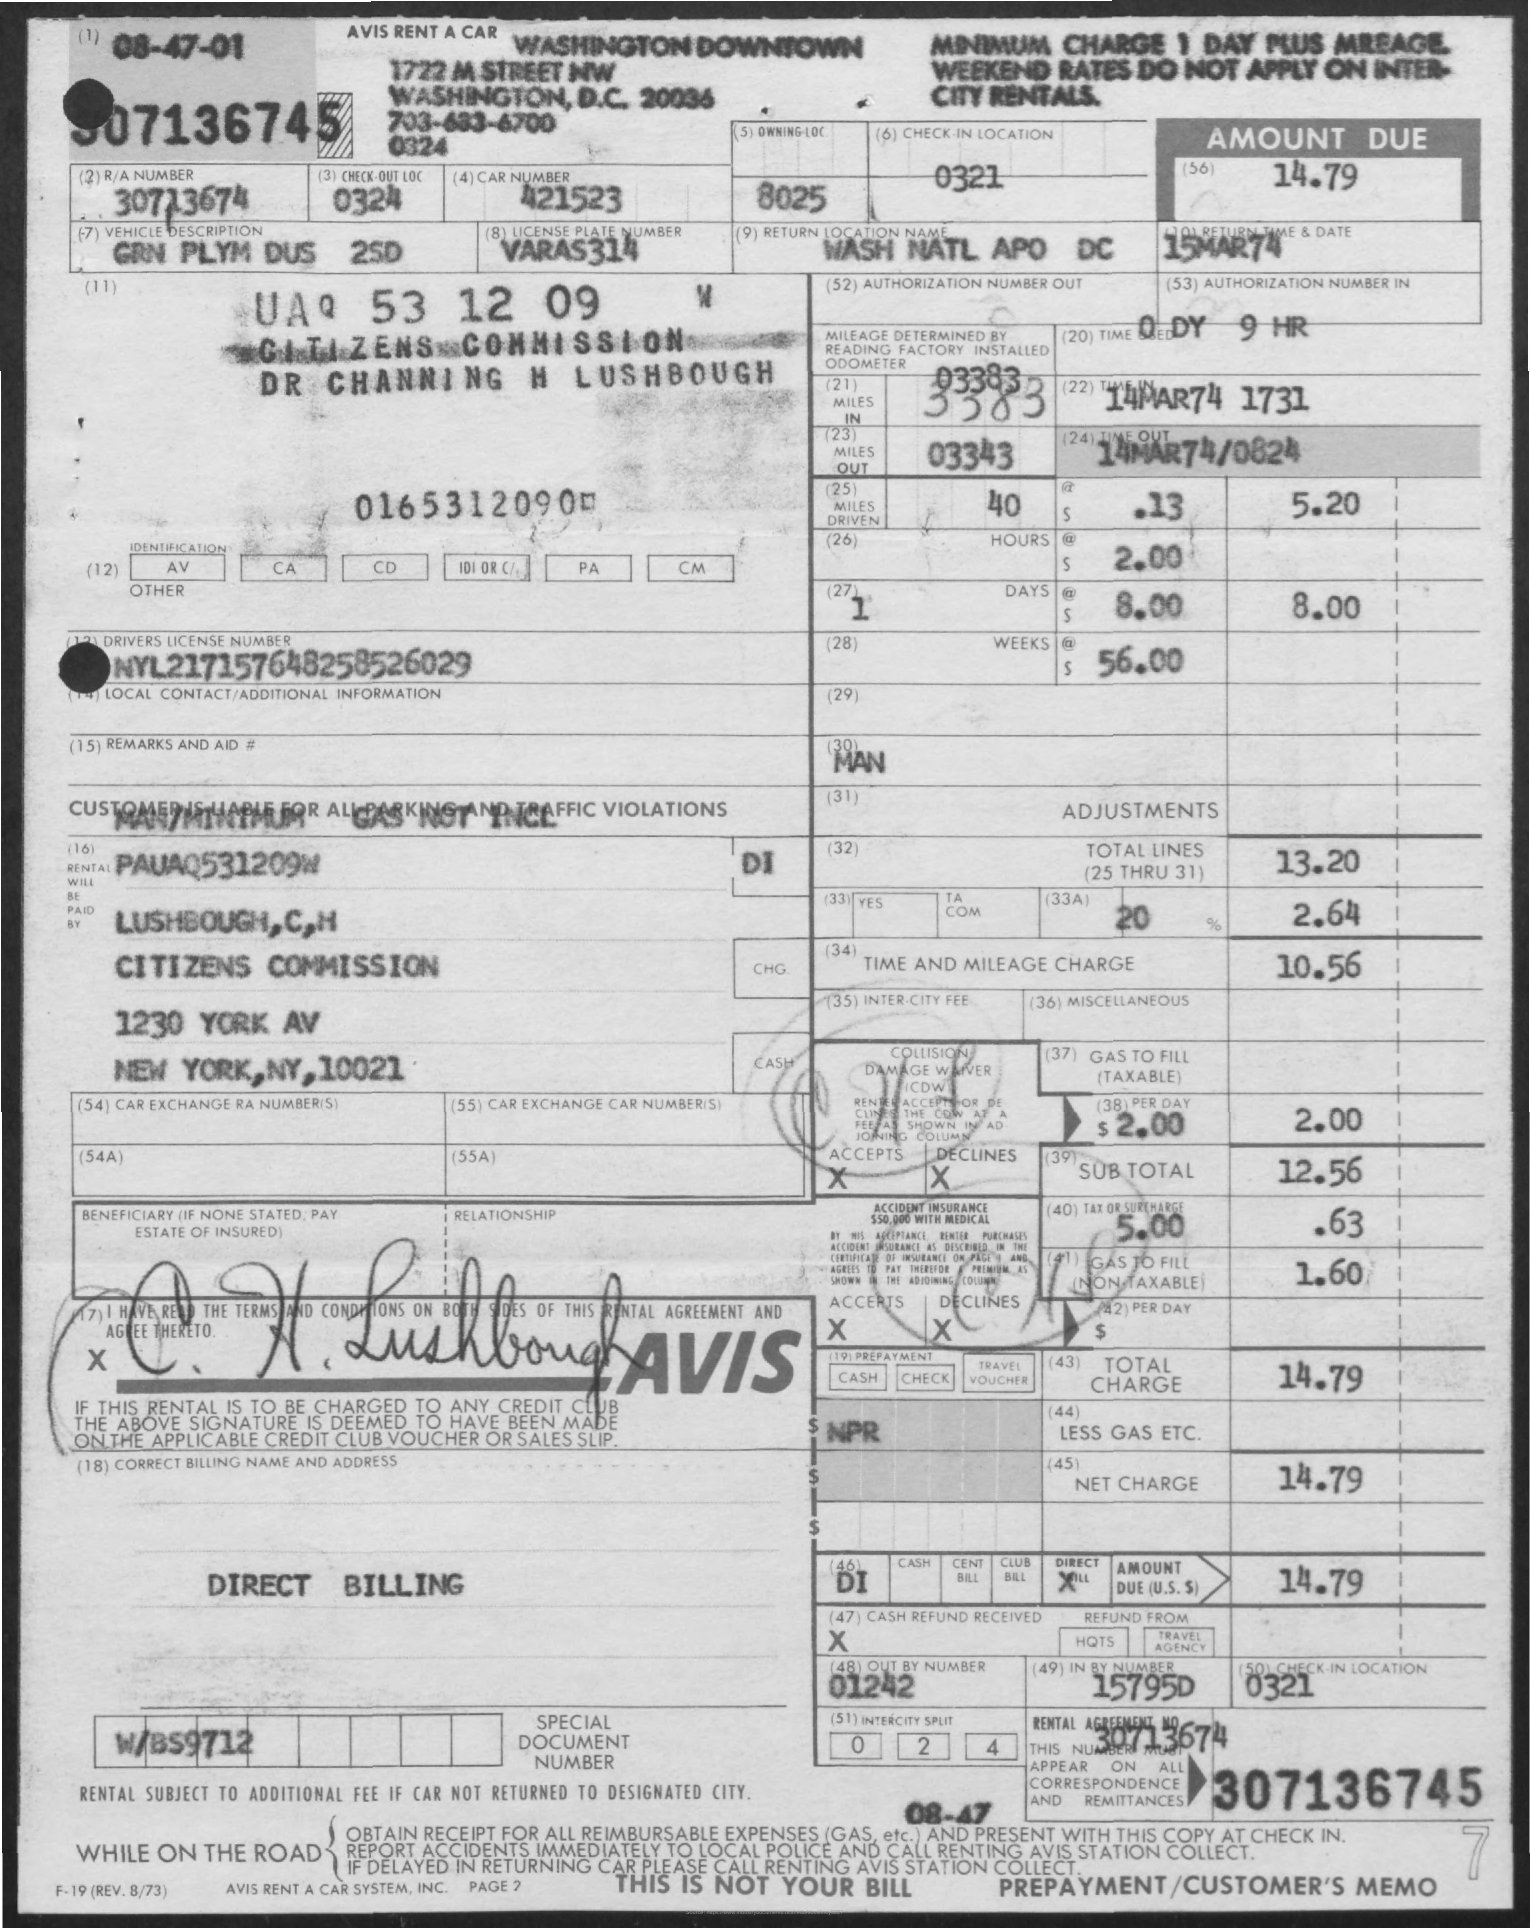What is the total amount due for this rental? The total amount due for the rental is $14.79, which is indicated in the 'Amount Due' and 'Net Charge' fields. 